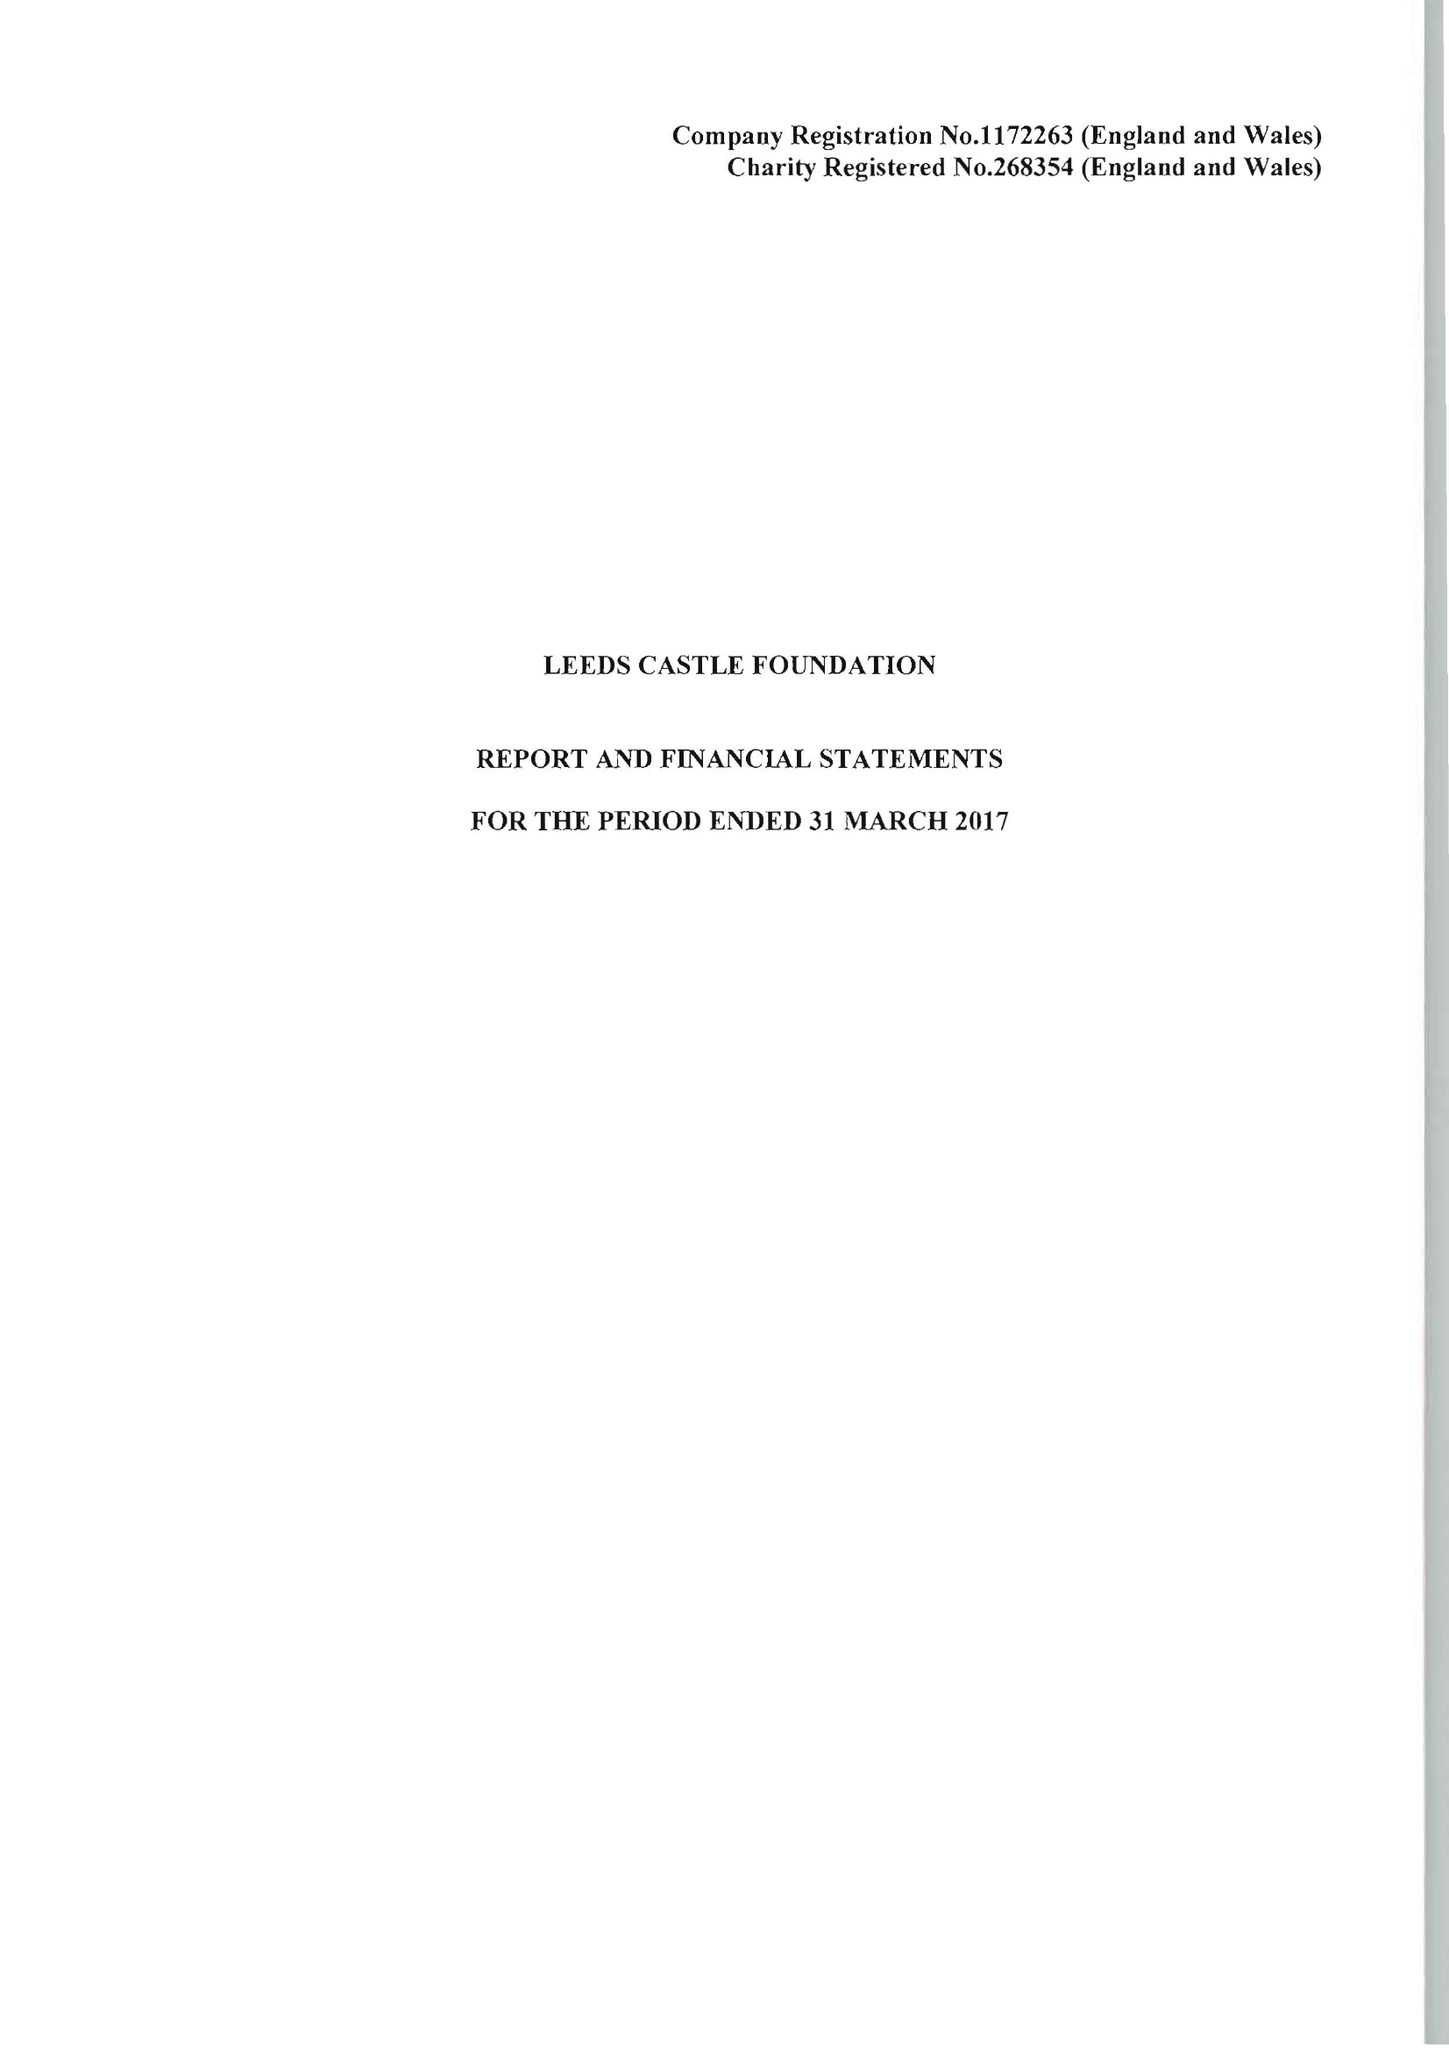What is the value for the charity_number?
Answer the question using a single word or phrase. 268354 